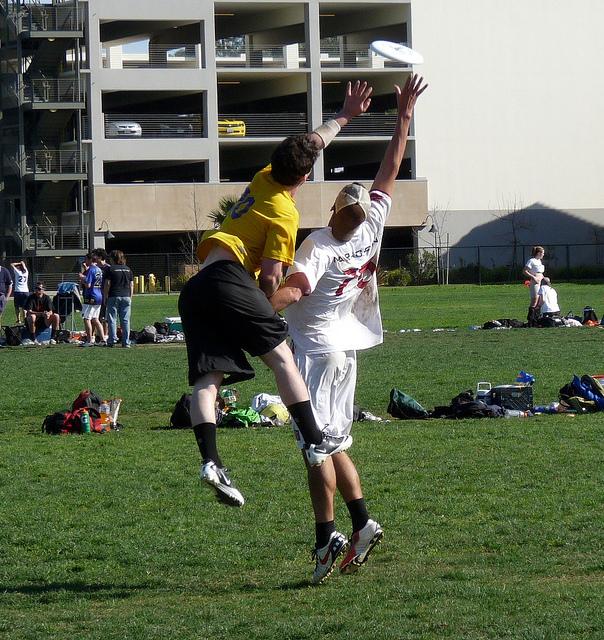Is the boy in yellow touching the ground?
Write a very short answer. No. Are these people outside?
Quick response, please. Yes. Is everyone standing up?
Keep it brief. No. How many people are sitting in the grass?
Give a very brief answer. 2. Is there a frisbee on the ground?
Be succinct. No. How many people are lying on the floor?
Quick response, please. 0. What are the men jumping to grab?
Short answer required. Frisbee. Is this person levitating?
Give a very brief answer. No. What color are the uniforms?
Concise answer only. White. 